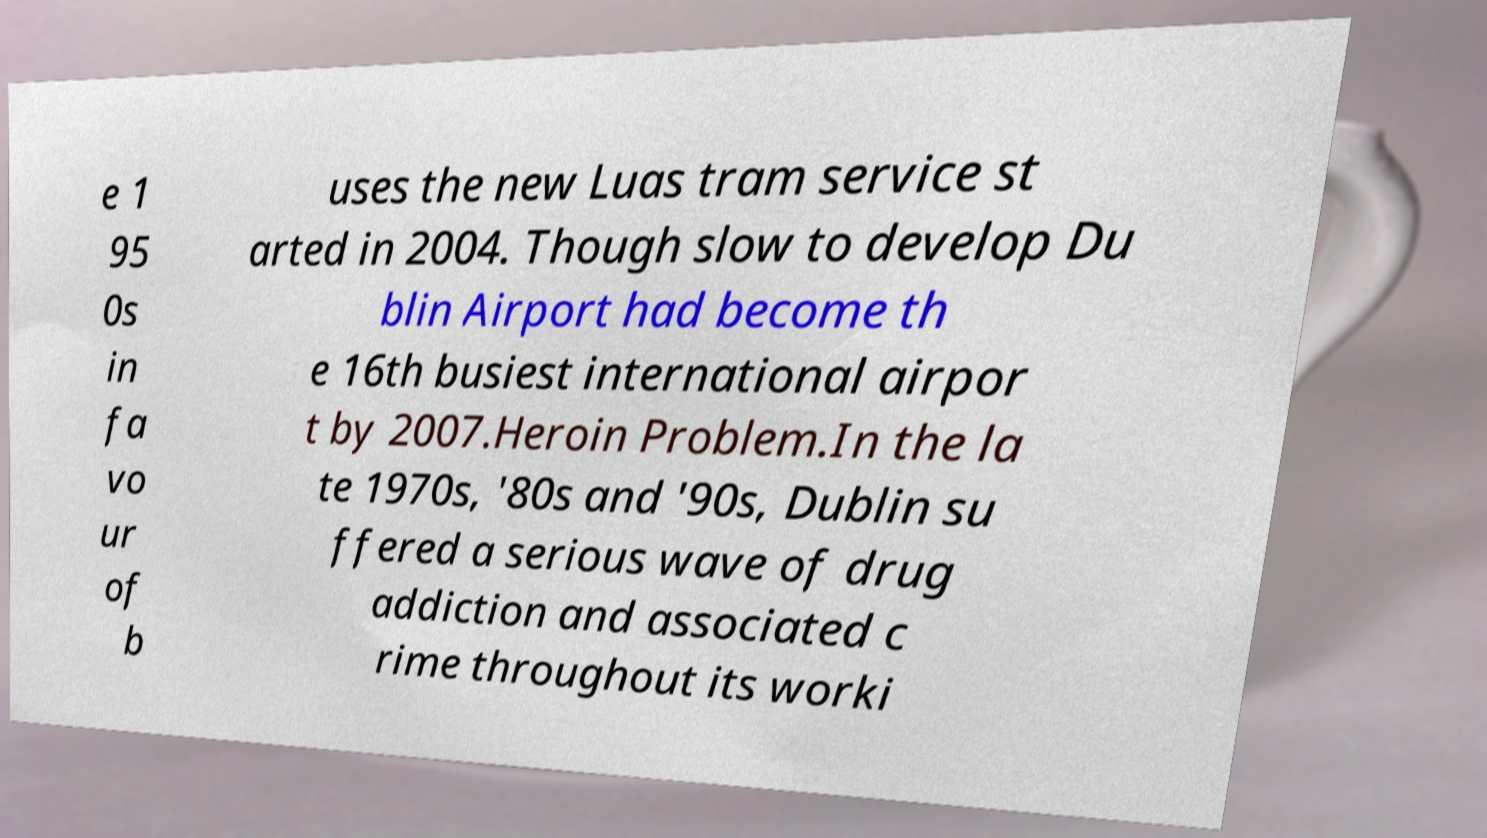Could you extract and type out the text from this image? e 1 95 0s in fa vo ur of b uses the new Luas tram service st arted in 2004. Though slow to develop Du blin Airport had become th e 16th busiest international airpor t by 2007.Heroin Problem.In the la te 1970s, '80s and '90s, Dublin su ffered a serious wave of drug addiction and associated c rime throughout its worki 